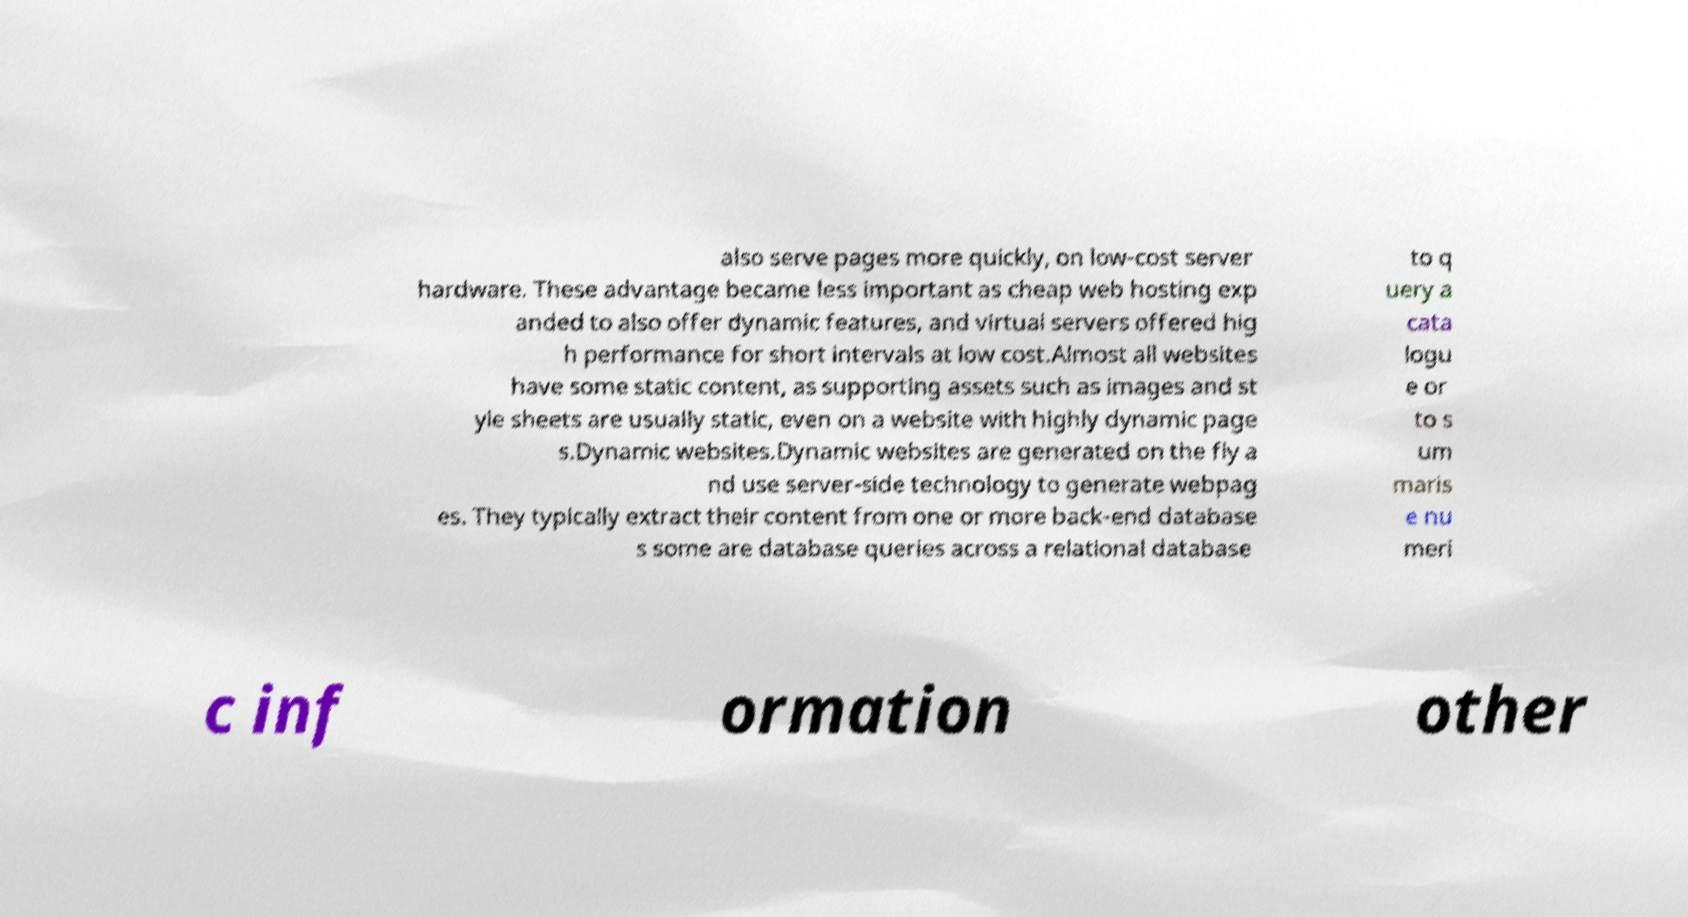What messages or text are displayed in this image? I need them in a readable, typed format. also serve pages more quickly, on low-cost server hardware. These advantage became less important as cheap web hosting exp anded to also offer dynamic features, and virtual servers offered hig h performance for short intervals at low cost.Almost all websites have some static content, as supporting assets such as images and st yle sheets are usually static, even on a website with highly dynamic page s.Dynamic websites.Dynamic websites are generated on the fly a nd use server-side technology to generate webpag es. They typically extract their content from one or more back-end database s some are database queries across a relational database to q uery a cata logu e or to s um maris e nu meri c inf ormation other 